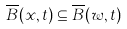<formula> <loc_0><loc_0><loc_500><loc_500>\overline { B } ( x , t ) \subseteq \overline { B } ( w , t )</formula> 